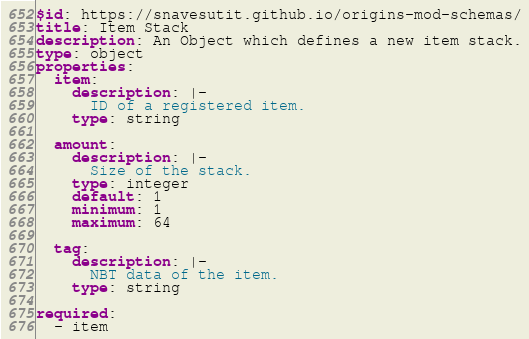Convert code to text. <code><loc_0><loc_0><loc_500><loc_500><_YAML_>$id: https://snavesutit.github.io/origins-mod-schemas/
title: Item Stack
description: An Object which defines a new item stack.
type: object
properties:
  item:
    description: |-
      ID of a registered item.
    type: string

  amount:
    description: |-
      Size of the stack.
    type: integer
    default: 1
    minimum: 1
    maximum: 64

  tag:
    description: |-
      NBT data of the item.
    type: string

required:
  - item
</code> 